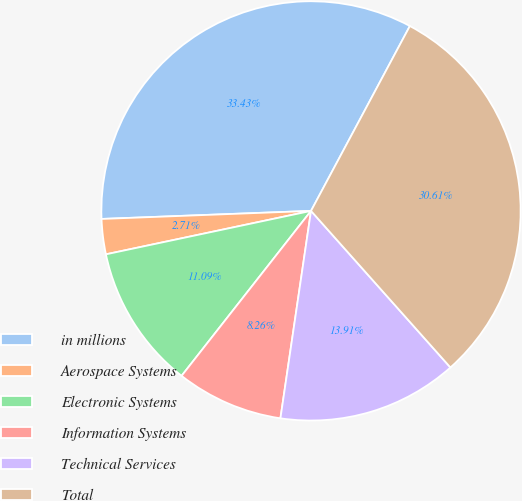<chart> <loc_0><loc_0><loc_500><loc_500><pie_chart><fcel>in millions<fcel>Aerospace Systems<fcel>Electronic Systems<fcel>Information Systems<fcel>Technical Services<fcel>Total<nl><fcel>33.43%<fcel>2.71%<fcel>11.09%<fcel>8.26%<fcel>13.91%<fcel>30.61%<nl></chart> 